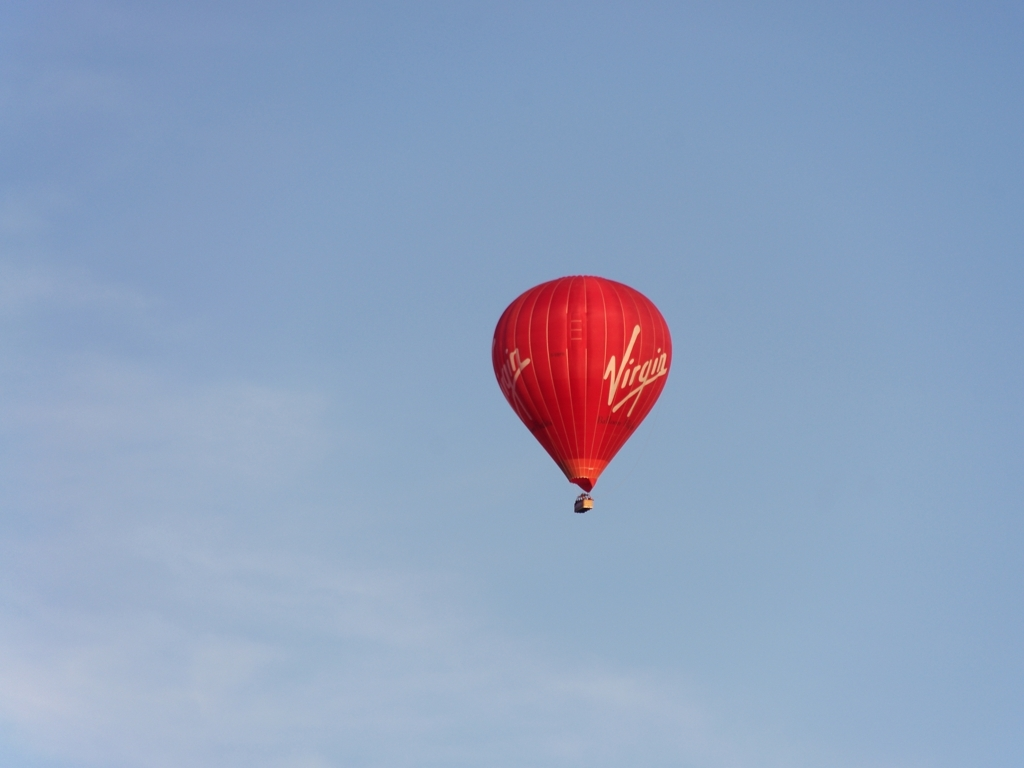What kind of aircraft is pictured in the image? The image shows a hot air balloon, which is a type of lighter-than-air aircraft that is propelled by heating the air inside the balloon envelope. Can you tell me about its design? Certainly, the balloon in the image is shaped like an inverted teardrop, which is typical for hot air balloons. Its design features the bright red color with the name 'Virgin' written on it, likely indicating it's operated by the Virgin Group. How does a hot air balloon work? Can you please explain? A hot air balloon operates on the principle that warmer air rises in cooler air. It works by using a burner to heat the air inside the balloon's envelope, which causes the balloon to rise because the hot air inside is less dense than the cooler air outside. Pilots can control the altitude by adjusting the temperature of the air within the balloon. 